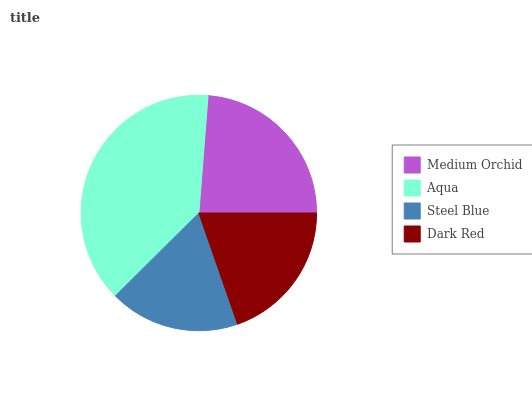Is Steel Blue the minimum?
Answer yes or no. Yes. Is Aqua the maximum?
Answer yes or no. Yes. Is Aqua the minimum?
Answer yes or no. No. Is Steel Blue the maximum?
Answer yes or no. No. Is Aqua greater than Steel Blue?
Answer yes or no. Yes. Is Steel Blue less than Aqua?
Answer yes or no. Yes. Is Steel Blue greater than Aqua?
Answer yes or no. No. Is Aqua less than Steel Blue?
Answer yes or no. No. Is Medium Orchid the high median?
Answer yes or no. Yes. Is Dark Red the low median?
Answer yes or no. Yes. Is Steel Blue the high median?
Answer yes or no. No. Is Steel Blue the low median?
Answer yes or no. No. 